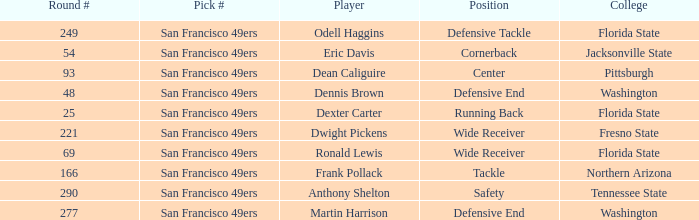What is the College with a Round # that is 290? Tennessee State. 